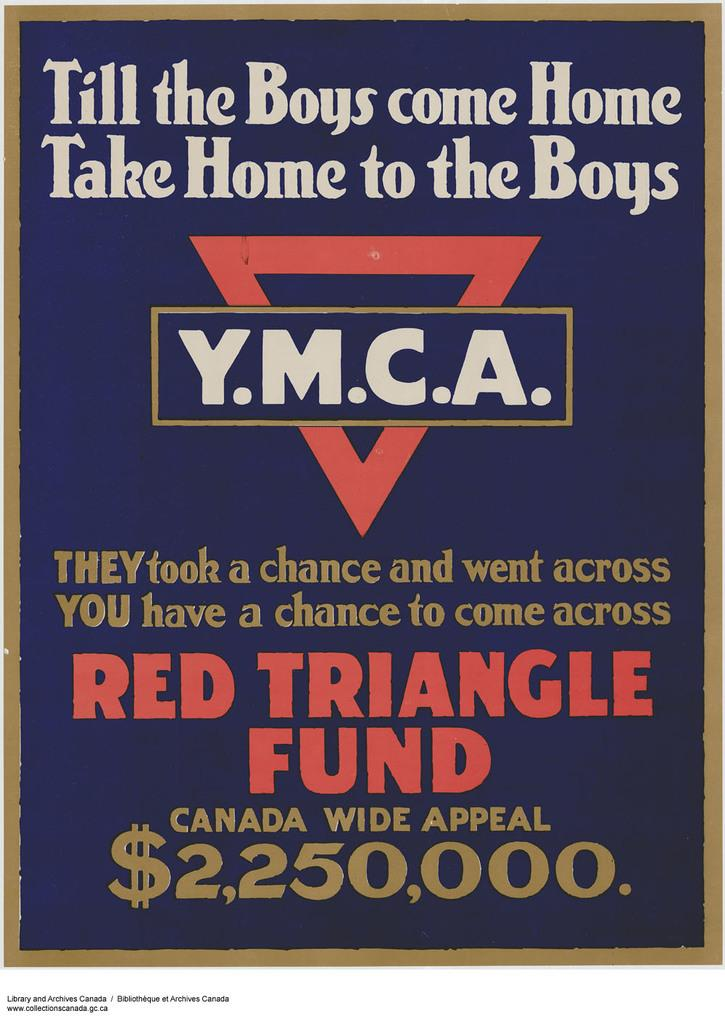What is written on the poster in the image? There is a quote written on the poster. Can you provide the name of the quote? The quote is named "Till boys come home, take home to the boys". What organization is associated with the poster? The Red Triangle Fund is written in the image. What type of motion is depicted in the image? There is no motion depicted in the image; it is a static poster with text. What role does coal play in the image? There is no mention of coal in the image; it features a quote and the Red Triangle Fund. 